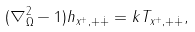Convert formula to latex. <formula><loc_0><loc_0><loc_500><loc_500>( \nabla _ { \Omega } ^ { 2 } - 1 ) h _ { x ^ { + } , + { \dot { + } } } = k T _ { x ^ { + } , + { \dot { + } } } ,</formula> 